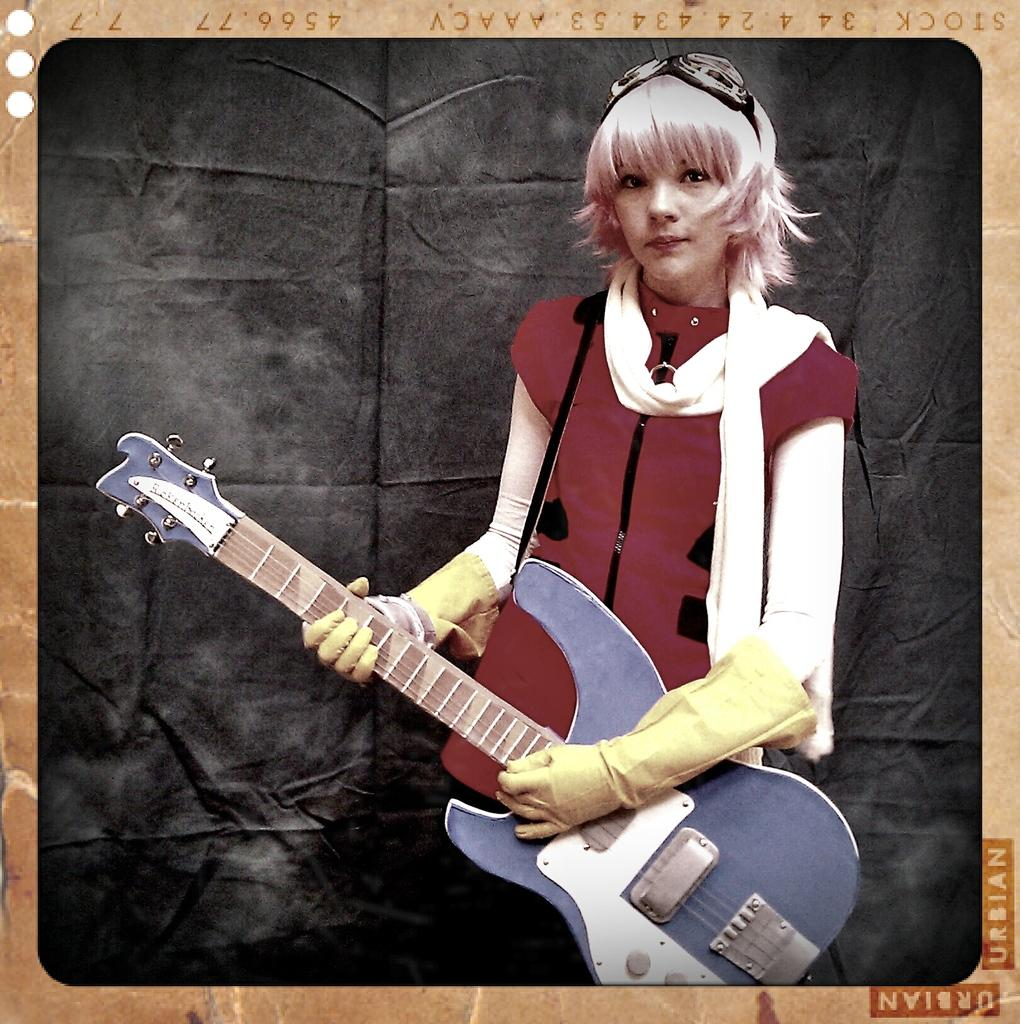Who is the main subject in the image? There is a woman in the image. What is the woman holding in the image? The woman is holding a guitar. What clothing items is the woman wearing? The woman is wearing yellow gloves and a red shirt. What can be seen in the background of the image? There is a black curtain in the background of the image. How is the image presented? The image is a photo frame. What type of creature is hiding behind the black curtain in the image? There is no creature hiding behind the black curtain in the image; it is a solid curtain with no openings or gaps. 